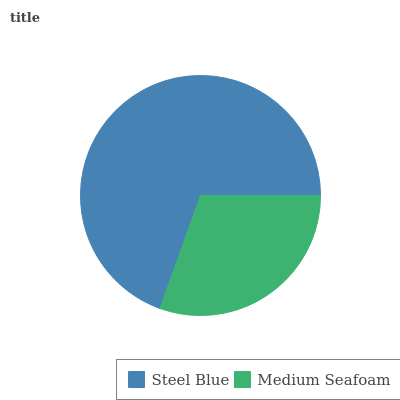Is Medium Seafoam the minimum?
Answer yes or no. Yes. Is Steel Blue the maximum?
Answer yes or no. Yes. Is Medium Seafoam the maximum?
Answer yes or no. No. Is Steel Blue greater than Medium Seafoam?
Answer yes or no. Yes. Is Medium Seafoam less than Steel Blue?
Answer yes or no. Yes. Is Medium Seafoam greater than Steel Blue?
Answer yes or no. No. Is Steel Blue less than Medium Seafoam?
Answer yes or no. No. Is Steel Blue the high median?
Answer yes or no. Yes. Is Medium Seafoam the low median?
Answer yes or no. Yes. Is Medium Seafoam the high median?
Answer yes or no. No. Is Steel Blue the low median?
Answer yes or no. No. 